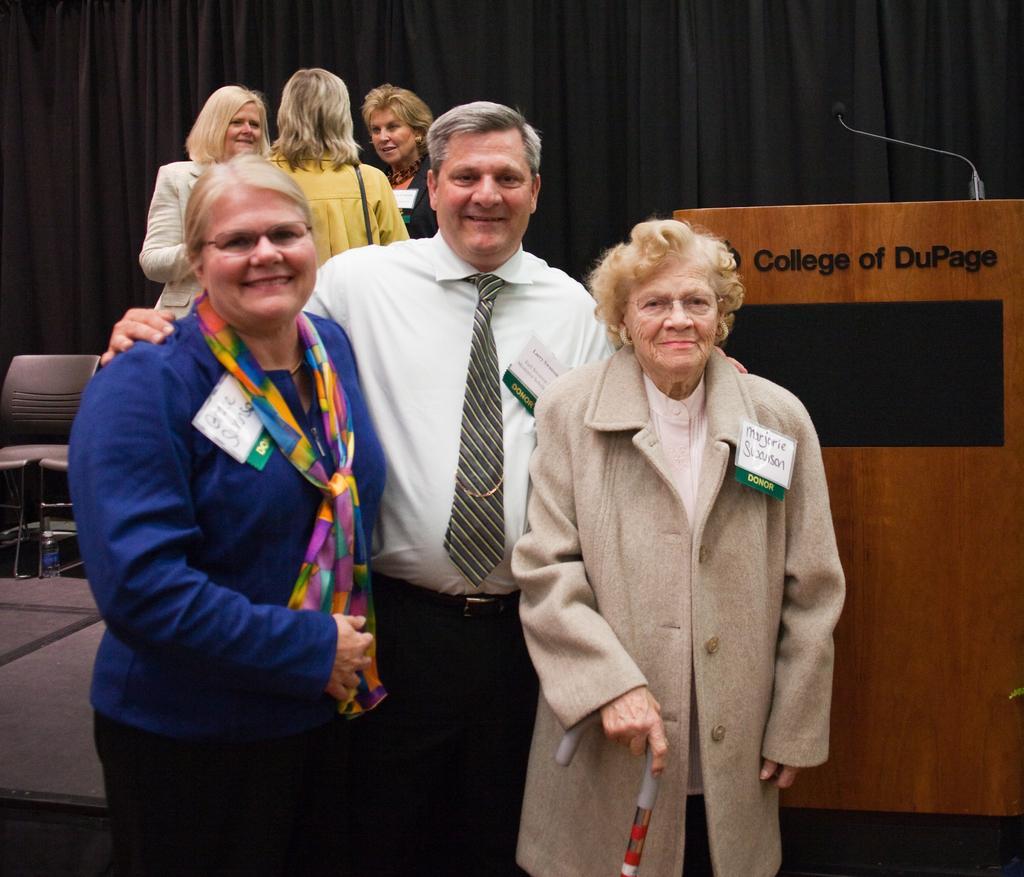Could you give a brief overview of what you see in this image? In this image we can see a group of people. In the foreground of the image we can see three people are standing and taking a photograph. On the top of the image we can see three people are talking to each other. 